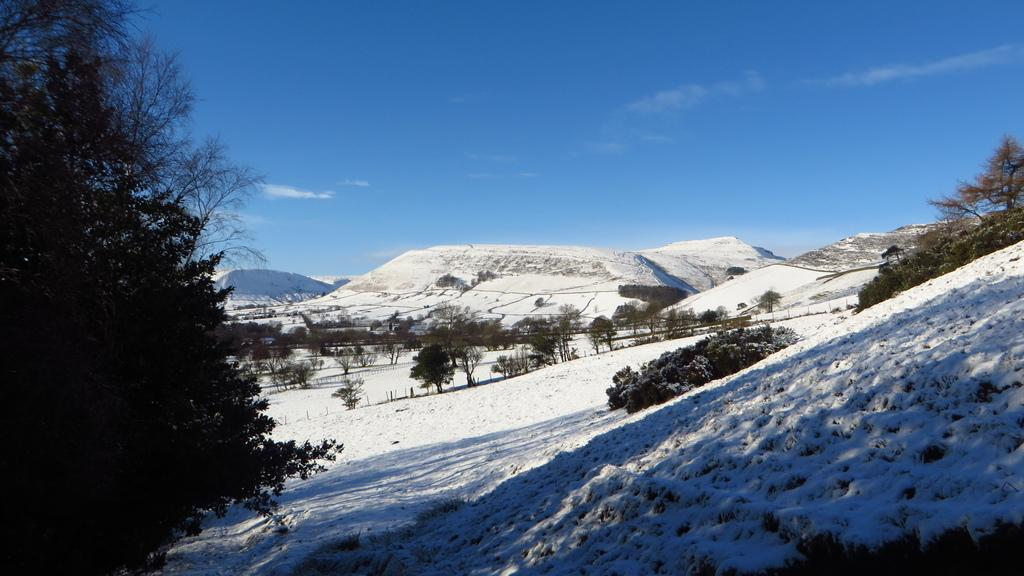What is the main feature in the middle of the image? There are snow mountains in the middle of the image. What can be seen on the left side of the image? There is a tree on the left side of the image. What type of vegetation is present in the snow between the mountains? There are trees in the snow between the mountains. What is visible at the top of the image? The sky is visible at the top of the image. Can you see a pot of soup boiling near the tree on the left side of the image? No, there is no pot of soup or any indication of fire in the image. Additionally, there is no giraffe present in the image. 